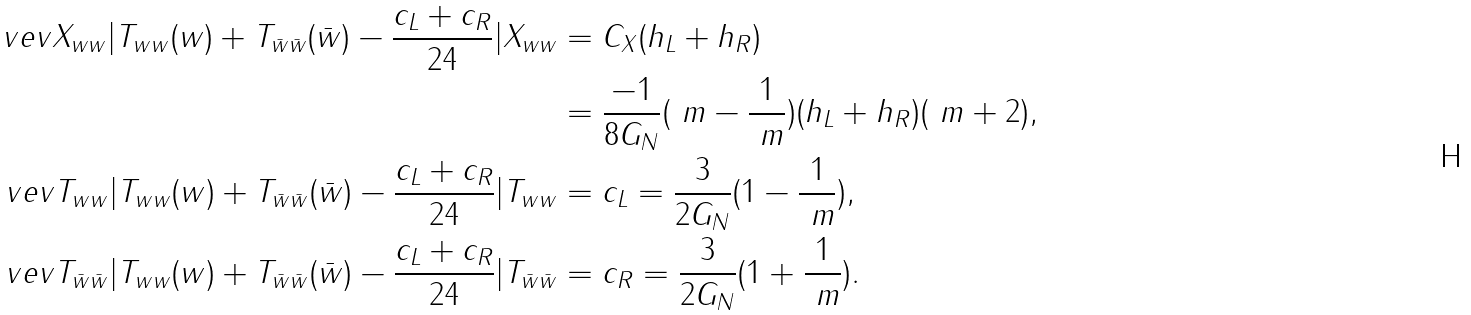<formula> <loc_0><loc_0><loc_500><loc_500>\ v e v { X _ { w w } | T _ { w w } ( w ) + T _ { \bar { w } \bar { w } } ( \bar { w } ) - \frac { c _ { L } + c _ { R } } { 2 4 } | X _ { w w } } & = C _ { X } ( h _ { L } + h _ { R } ) \\ & = \frac { - 1 } { 8 G _ { N } } ( \ m - \frac { 1 } { \ m } ) ( h _ { L } + h _ { R } ) ( \ m + 2 ) , \\ \ v e v { T _ { w w } | T _ { w w } ( w ) + T _ { \bar { w } \bar { w } } ( \bar { w } ) - \frac { c _ { L } + c _ { R } } { 2 4 } | T _ { w w } } & = c _ { L } = \frac { 3 } { 2 G _ { N } } ( 1 - \frac { 1 } { \ m } ) , \\ \ v e v { T _ { \bar { w } \bar { w } } | T _ { w w } ( w ) + T _ { \bar { w } \bar { w } } ( \bar { w } ) - \frac { c _ { L } + c _ { R } } { 2 4 } | T _ { \bar { w } \bar { w } } } & = c _ { R } = \frac { 3 } { 2 G _ { N } } ( 1 + \frac { 1 } { \ m } ) .</formula> 